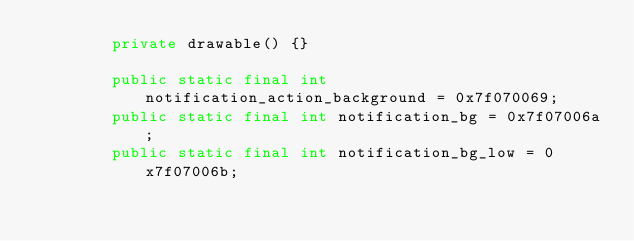Convert code to text. <code><loc_0><loc_0><loc_500><loc_500><_Java_>        private drawable() {}

        public static final int notification_action_background = 0x7f070069;
        public static final int notification_bg = 0x7f07006a;
        public static final int notification_bg_low = 0x7f07006b;</code> 